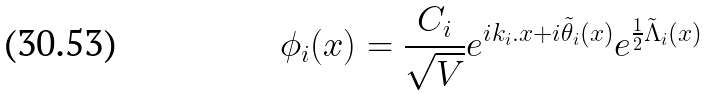Convert formula to latex. <formula><loc_0><loc_0><loc_500><loc_500>\phi _ { i } ( { x } ) = \frac { C _ { i } } { \sqrt { V } } e ^ { i { k } _ { i } . { x } + i { \tilde { \theta } } _ { i } ( { x } ) } e ^ { \frac { 1 } { 2 } { \tilde { \Lambda } } _ { i } ( { x } ) }</formula> 